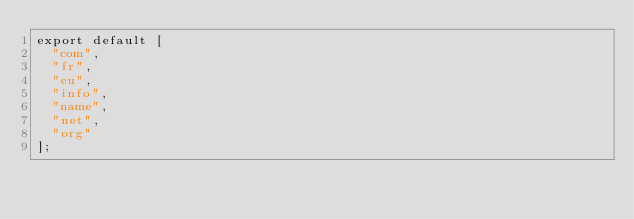Convert code to text. <code><loc_0><loc_0><loc_500><loc_500><_JavaScript_>export default [
  "com",
  "fr",
  "eu",
  "info",
  "name",
  "net",
  "org"
];
</code> 